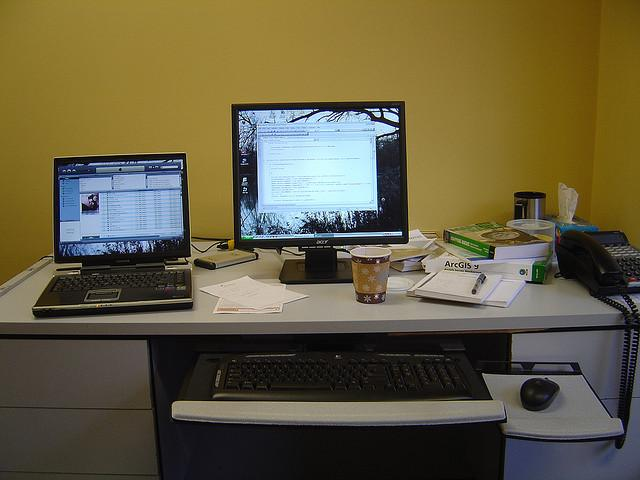Why would someone sit here?

Choices:
A) to work
B) to paint
C) to wait
D) to eat to work 